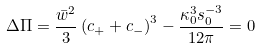<formula> <loc_0><loc_0><loc_500><loc_500>\Delta \Pi = \frac { \bar { w } ^ { 2 } } { 3 } \left ( c _ { + } + c _ { - } \right ) ^ { 3 } - \frac { \kappa _ { 0 } ^ { 3 } s _ { 0 } ^ { - 3 } } { 1 2 \pi } = 0</formula> 